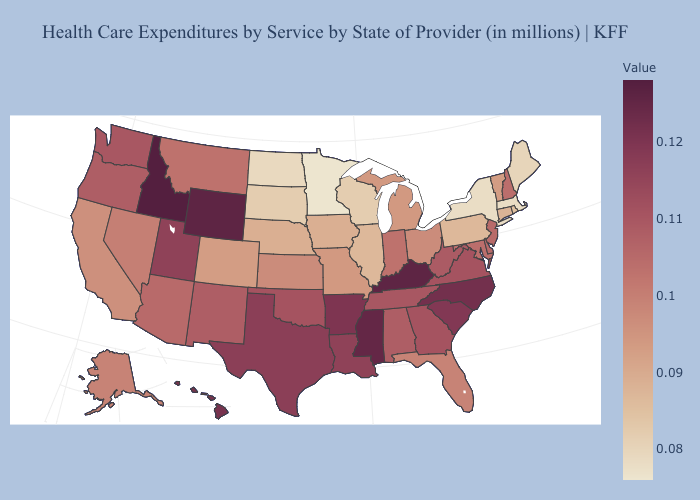Among the states that border West Virginia , does Pennsylvania have the lowest value?
Short answer required. Yes. Does the map have missing data?
Quick response, please. No. 